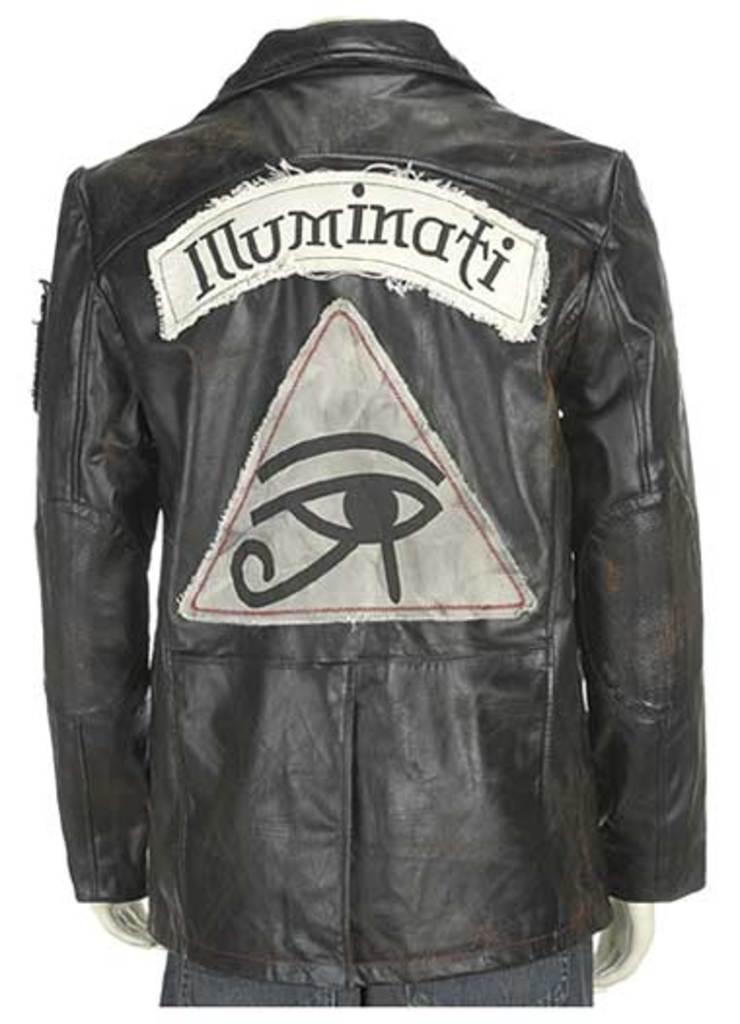What is the main subject of the image? There is a headless mannequin in the image. What type of clothing is the mannequin wearing? The mannequin is wearing a black jacket and jeans. What color is the background of the image? The background of the image is white in color. How much debt does the mannequin have in the image? There is no information about the mannequin's debt in the image, as it is an inanimate object. 